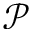<formula> <loc_0><loc_0><loc_500><loc_500>\mathcal { P }</formula> 